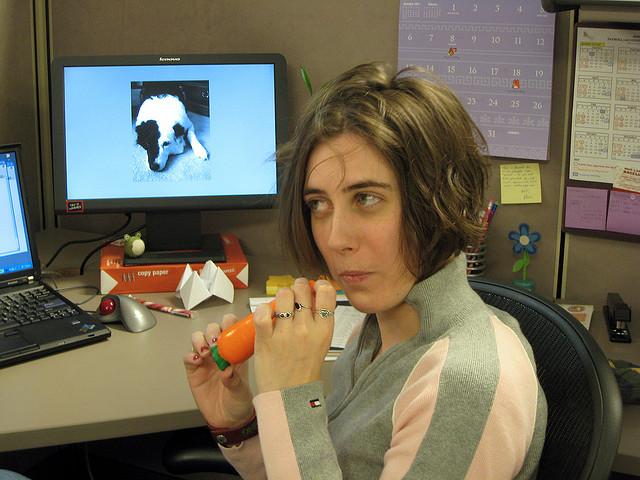Is she drinking juice?
Keep it brief. No. Are the screens on?
Be succinct. Yes. What is the print on the woman's shirt?
Write a very short answer. Stripes. Is the desk organized?
Keep it brief. Yes. Is this woman competitive?
Concise answer only. No. What gift did she get?
Answer briefly. Carrot. Is there a telephone in the photo?
Be succinct. No. What room is this?
Give a very brief answer. Office. Is that a modern monitor?
Answer briefly. Yes. What is the sharp object the person has in their hand?
Concise answer only. Carrot. What animal is on the monitor?
Concise answer only. Dog. What color is her hair?
Answer briefly. Brown. 